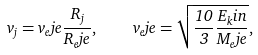<formula> <loc_0><loc_0><loc_500><loc_500>v _ { j } = v _ { e } j e \frac { R _ { j } } { R _ { e } j e } , \quad v _ { e } j e = \sqrt { \frac { 1 0 } { 3 } \frac { E _ { k } i n } { M _ { e } j e } } ,</formula> 